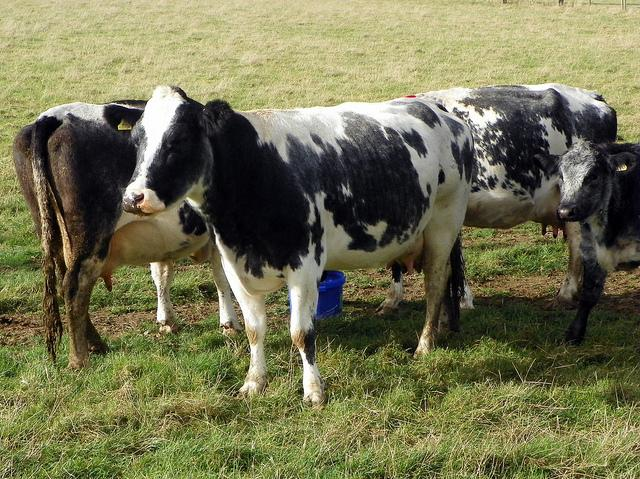Which animal look different than the cows in the picture? calf 